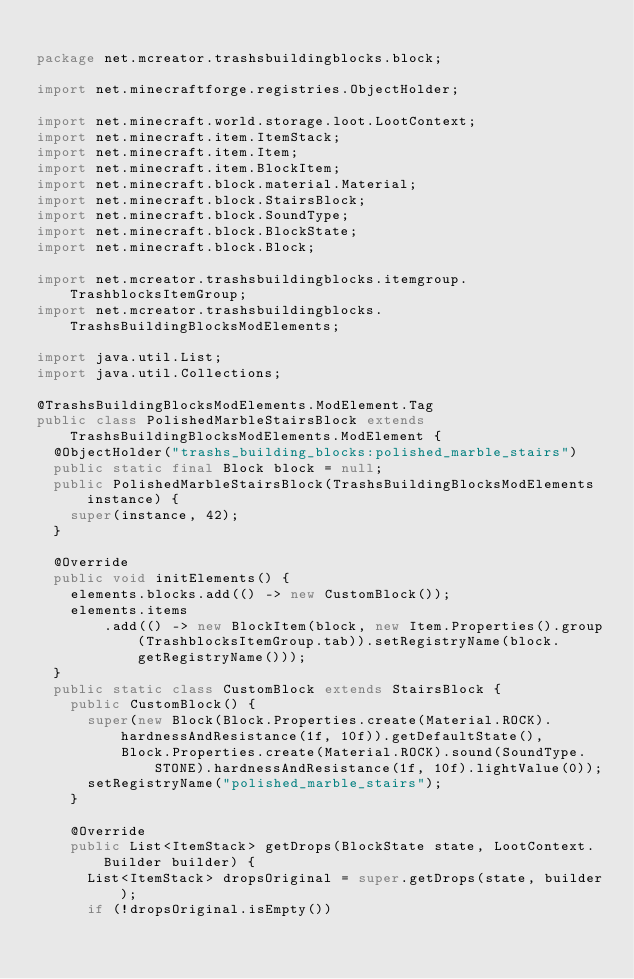<code> <loc_0><loc_0><loc_500><loc_500><_Java_>
package net.mcreator.trashsbuildingblocks.block;

import net.minecraftforge.registries.ObjectHolder;

import net.minecraft.world.storage.loot.LootContext;
import net.minecraft.item.ItemStack;
import net.minecraft.item.Item;
import net.minecraft.item.BlockItem;
import net.minecraft.block.material.Material;
import net.minecraft.block.StairsBlock;
import net.minecraft.block.SoundType;
import net.minecraft.block.BlockState;
import net.minecraft.block.Block;

import net.mcreator.trashsbuildingblocks.itemgroup.TrashblocksItemGroup;
import net.mcreator.trashsbuildingblocks.TrashsBuildingBlocksModElements;

import java.util.List;
import java.util.Collections;

@TrashsBuildingBlocksModElements.ModElement.Tag
public class PolishedMarbleStairsBlock extends TrashsBuildingBlocksModElements.ModElement {
	@ObjectHolder("trashs_building_blocks:polished_marble_stairs")
	public static final Block block = null;
	public PolishedMarbleStairsBlock(TrashsBuildingBlocksModElements instance) {
		super(instance, 42);
	}

	@Override
	public void initElements() {
		elements.blocks.add(() -> new CustomBlock());
		elements.items
				.add(() -> new BlockItem(block, new Item.Properties().group(TrashblocksItemGroup.tab)).setRegistryName(block.getRegistryName()));
	}
	public static class CustomBlock extends StairsBlock {
		public CustomBlock() {
			super(new Block(Block.Properties.create(Material.ROCK).hardnessAndResistance(1f, 10f)).getDefaultState(),
					Block.Properties.create(Material.ROCK).sound(SoundType.STONE).hardnessAndResistance(1f, 10f).lightValue(0));
			setRegistryName("polished_marble_stairs");
		}

		@Override
		public List<ItemStack> getDrops(BlockState state, LootContext.Builder builder) {
			List<ItemStack> dropsOriginal = super.getDrops(state, builder);
			if (!dropsOriginal.isEmpty())</code> 